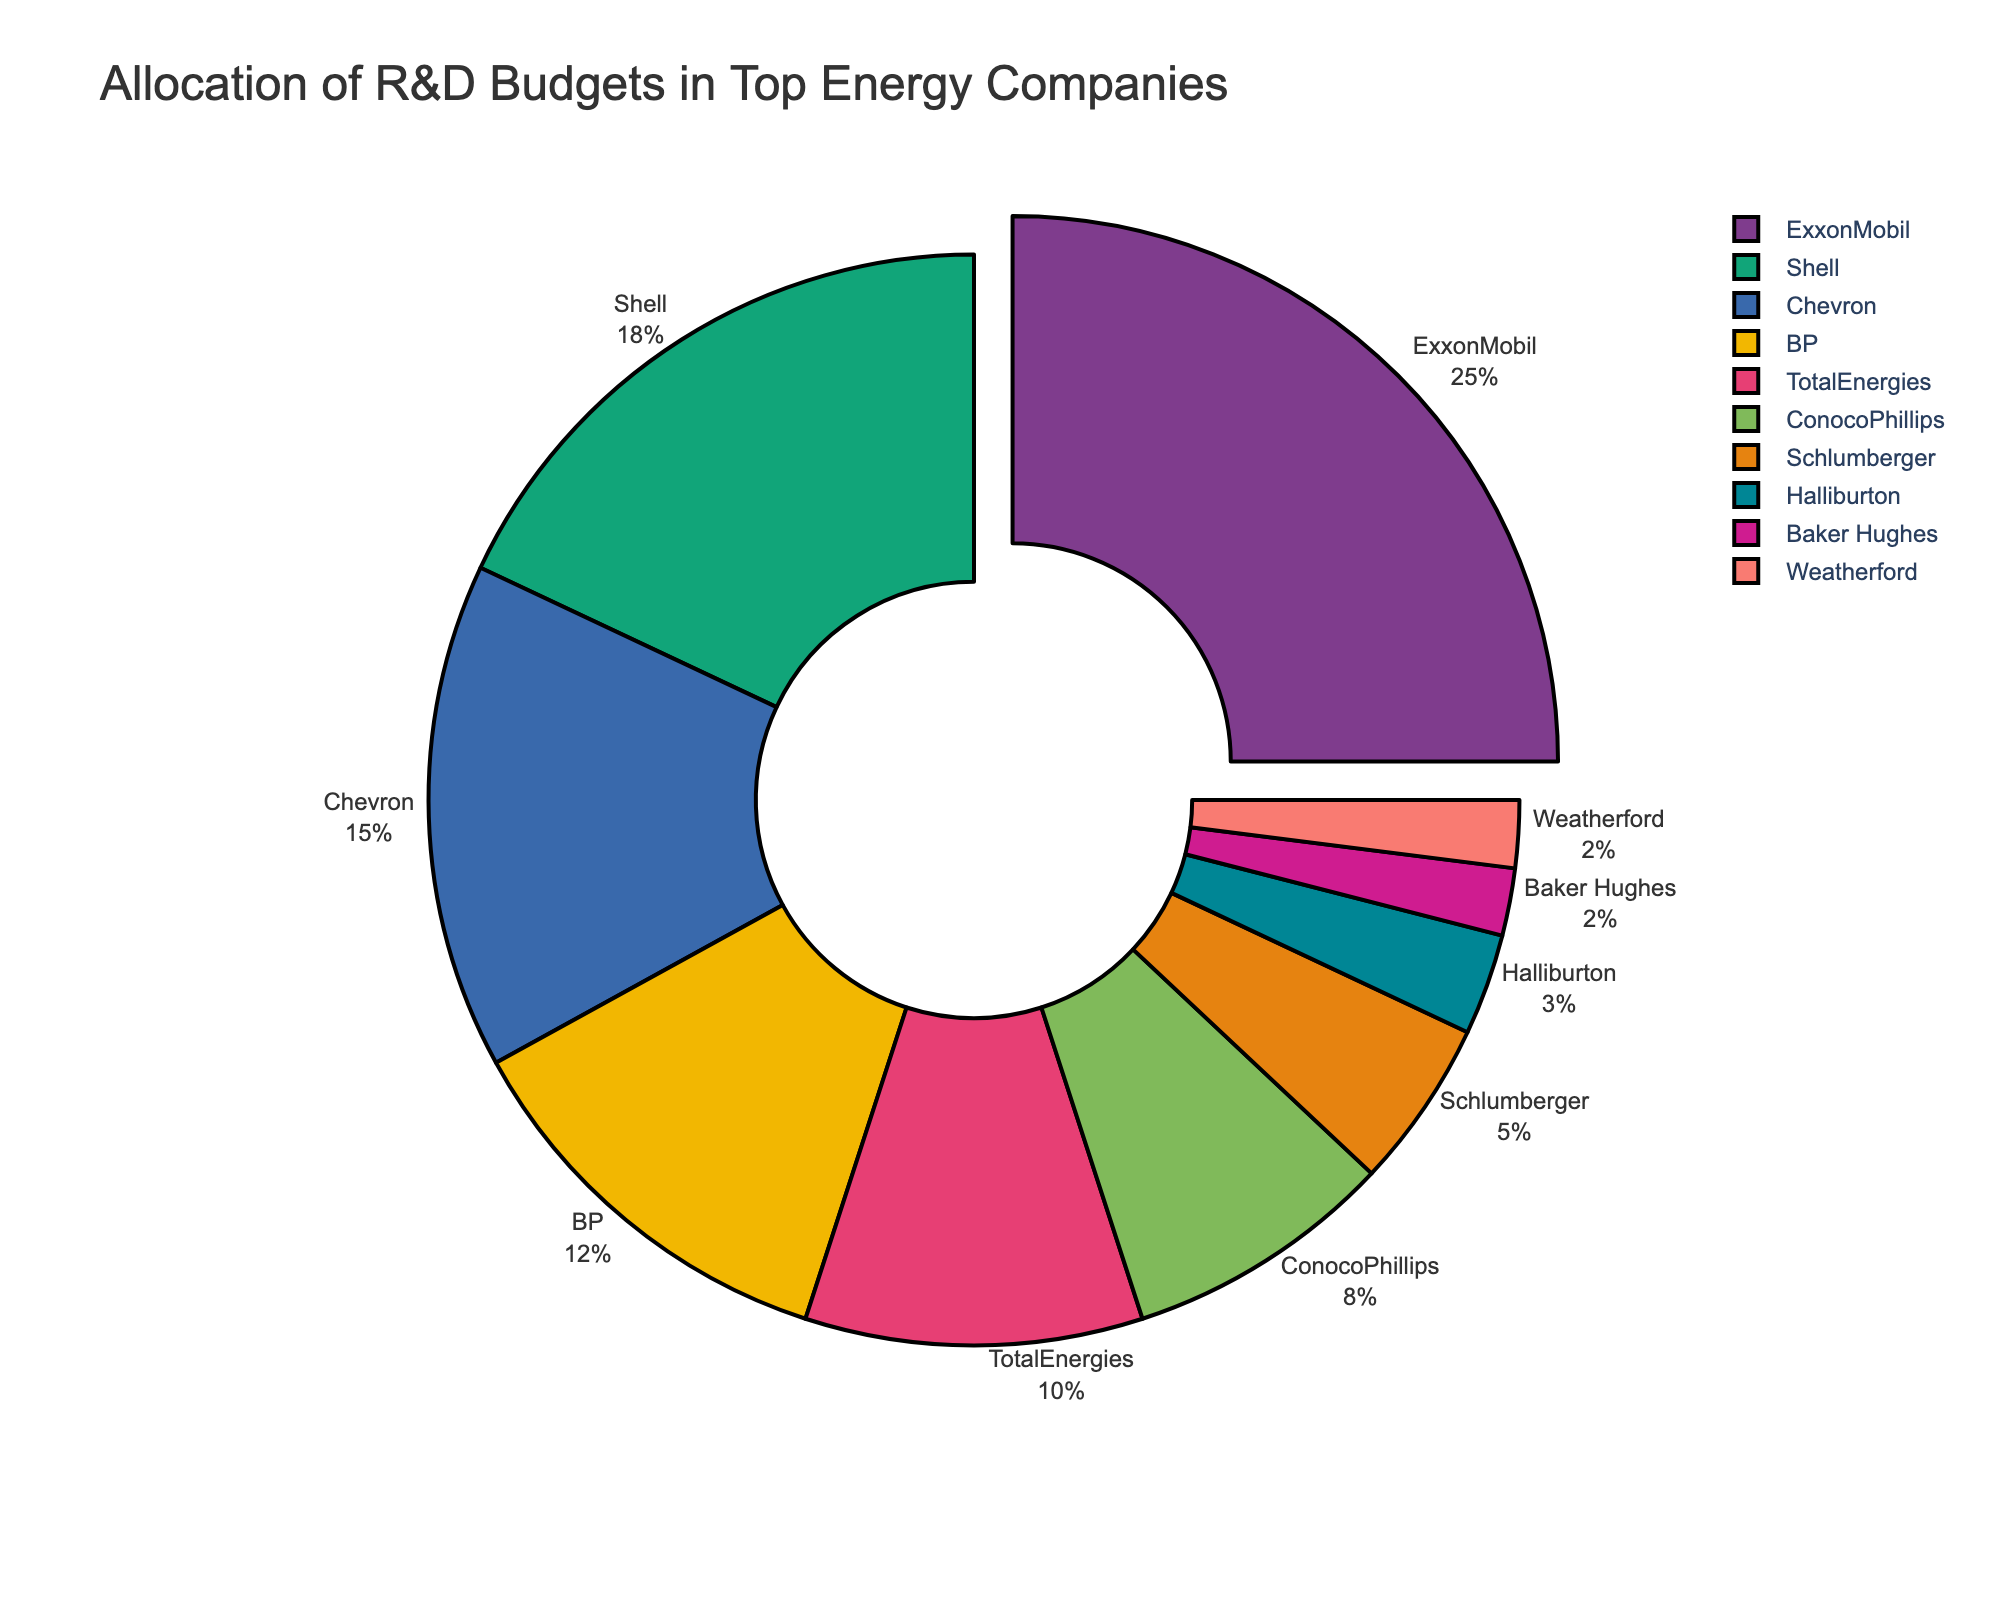What's the company with the highest R&D budget allocation? To determine the company with the highest R&D budget allocation, refer to the portion of the pie chart that is the largest. ExxonMobil has the largest segment in the chart.
Answer: ExxonMobil Which companies have a budget allocation less than 5%? Look at the pie chart segments and identify those with percentages less than 5%. These are Baker Hughes, Weatherford, and Halliburton.
Answer: Baker Hughes, Weatherford, Halliburton How much more is ExxonMobil's R&D budget allocation compared to Chevron's? ExxonMobil's allocation is 25%, and Chevron's allocation is 15%. The difference is calculated as 25% - 15%.
Answer: 10% What is the combined R&D budget allocation of Shell and BP? Shell's allocation is 18%, and BP's allocation is 12%. Summing these percentages gives the combined total.
Answer: 30% Which segment is visually pulled out from the pie chart, and why? The segment pulled out from the pie chart appears to be that of ExxonMobil, likely to emphasize its largest allocation in comparison to the others.
Answer: ExxonMobil Which company’s R&D budget allocation is closest to ConocoPhillips? ConocoPhillips has an 8% budget allocation. The closest percentage to this is Schlumberger with 5%.
Answer: Schlumberger How does the allocation of TotalEnergies compare to Chevron's? TotalEnergies has a 10% allocation, while Chevron has a 15% allocation. Chevron's allocation is higher.
Answer: Chevron's allocation is higher What is the mean R&D budget allocation percentage of the bottom five companies? The bottom five companies are ConocoPhillips (8%), Schlumberger (5%), Halliburton (3%), Baker Hughes (2%), and Weatherford (2%). The sum is 8% + 5% + 3% + 2% + 2% = 20%, and the average is 20% / 5.
Answer: 4% Identify the two companies with the closest R&D budget allocations and mention their allocations. The closest allocations are Baker Hughes and Weatherford, each with 2%.
Answer: Baker Hughes, Weatherford What is the overall visual layout and theme of the pie chart? The pie chart has a central hole, uses bold colors, displays labels outside, and highlights the largest segment. The overall focus is on clarity and visual impact.
Answer: Central hole, bold colors, labels outside, largest segment highlighted 